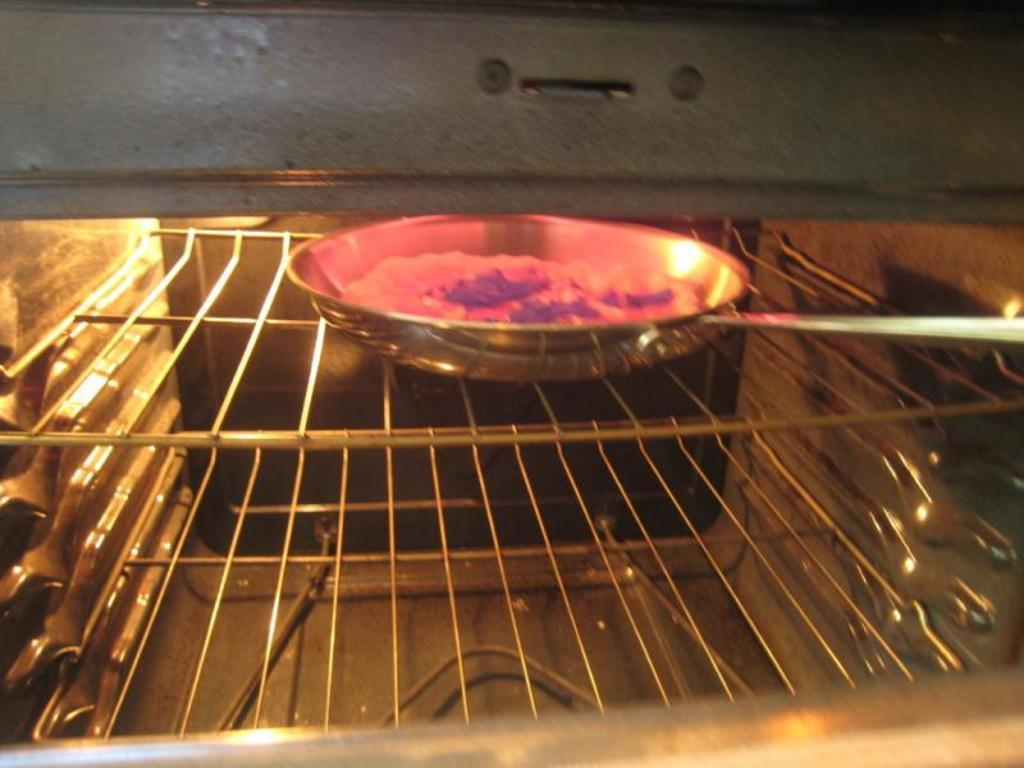What type of cooking equipment is in the image? There is a steel pan in the image. Where is the steel pan located? The steel pan is on a grill. What is inside the steel pan? There is an unspecified object in the pan. What type of vessel is used to transport the thumb in the image? There is no vessel or thumb present in the image. How many tomatoes are visible in the image? There are no tomatoes present in the image. 